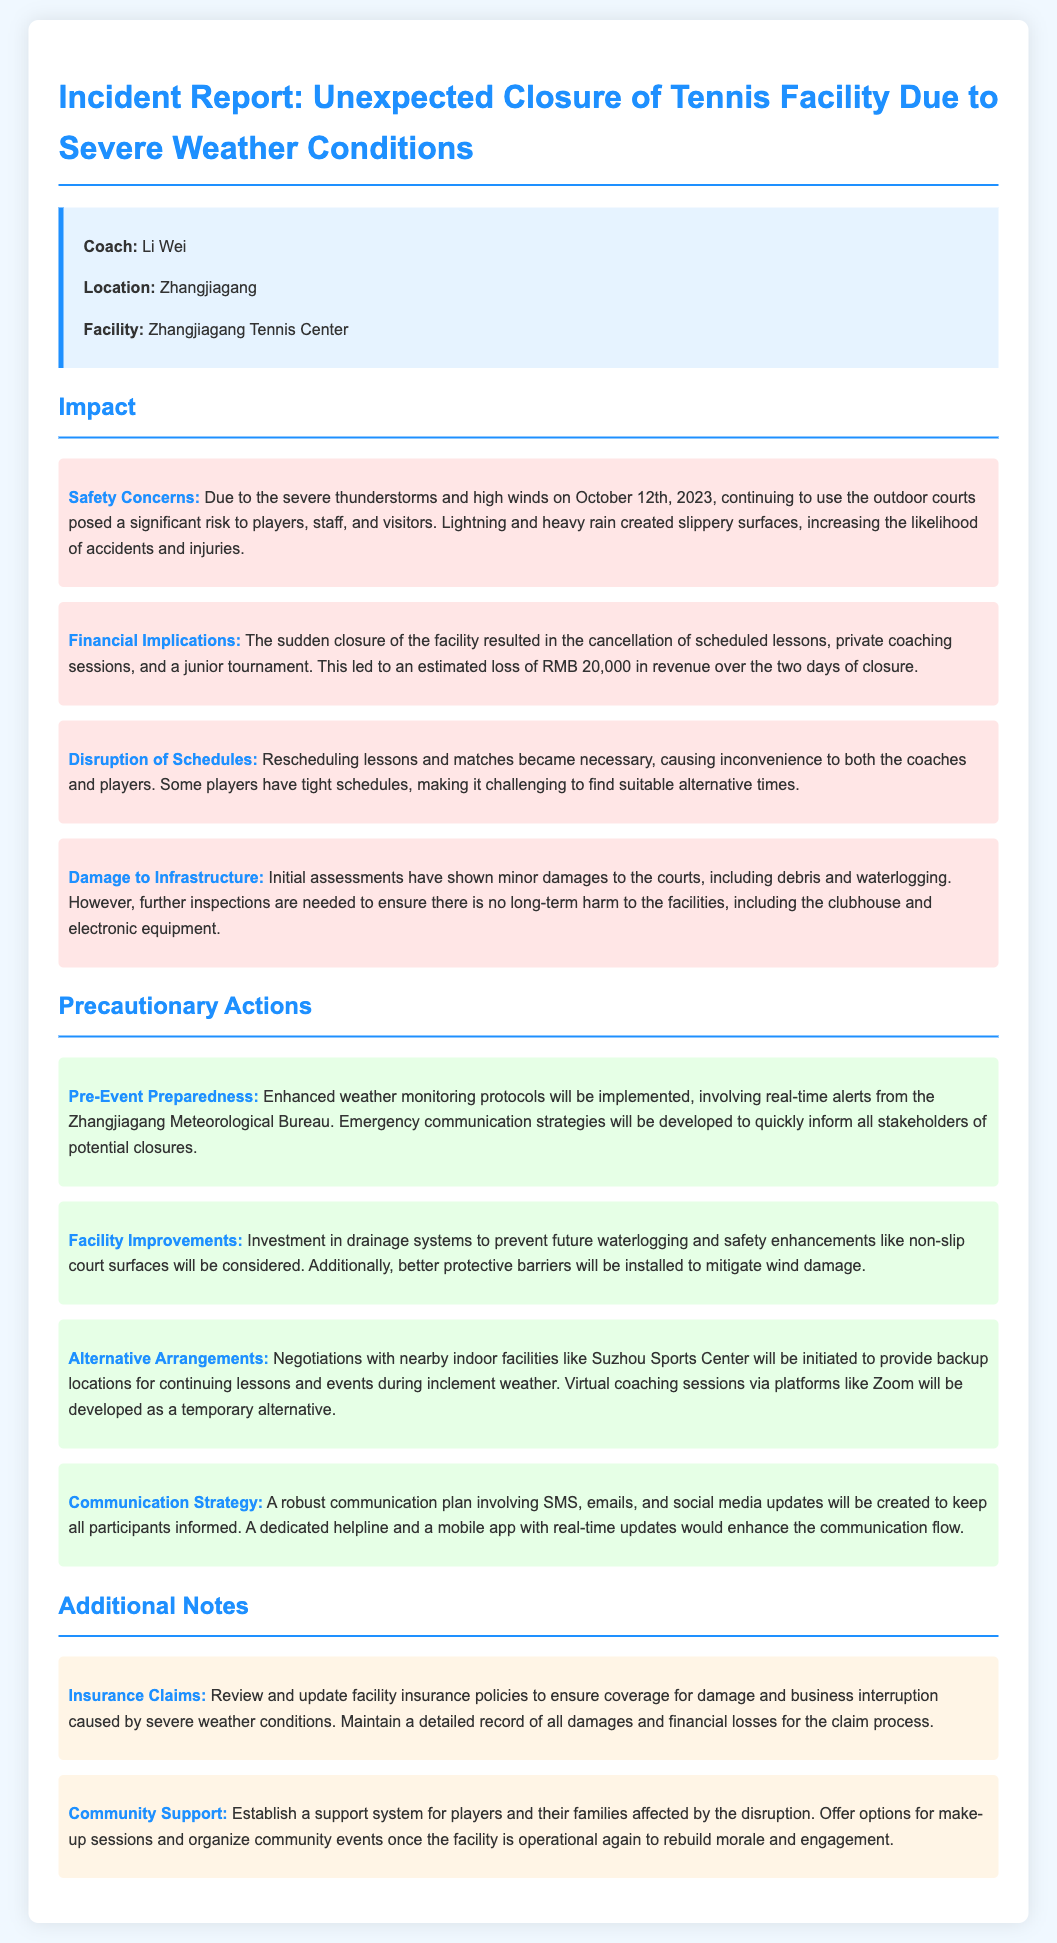What was the date of the severe weather incident? The date of the severe weather incident is stated in the document as October 12th, 2023.
Answer: October 12th, 2023 What was the estimated loss of revenue? The document notes that the estimated loss of revenue due to the closure was RMB 20,000.
Answer: RMB 20,000 Who is the coach mentioned in the report? The report identifies Coach Li Wei as the person in charge of the facility.
Answer: Li Wei What precautionary action involves negotiations with other facilities? The document mentions "Alternative Arrangements" as the precautionary action involving negotiations with nearby facilities.
Answer: Alternative Arrangements What type of communication plan is being developed? A "robust communication plan" involving SMS, emails, and social media updates is being developed as specified in the document.
Answer: robust communication plan What is a potential improvement mentioned for the facility? The report outlines "investment in drainage systems" as a facility improvement to prevent future waterlogging.
Answer: investment in drainage systems How will players be supported post-closure? The document discusses establishing a "support system for players and their families affected by the disruption" as a way to provide support.
Answer: support system What were the reported damages to the infrastructure? The initial assessments report "minor damages to the courts, including debris and waterlogging."
Answer: minor damages to the courts What financial aspect is being reviewed for future incidents? The document states that "insurance claims" are being reviewed and updated to ensure coverage for severe weather impacts.
Answer: insurance claims 